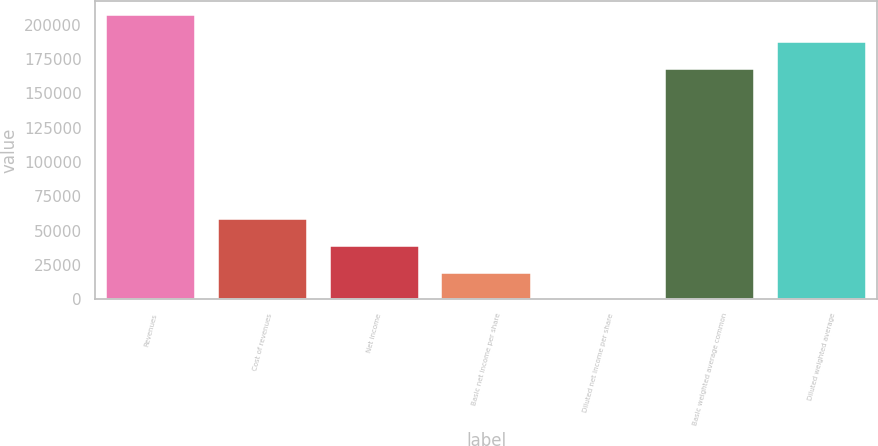Convert chart. <chart><loc_0><loc_0><loc_500><loc_500><bar_chart><fcel>Revenues<fcel>Cost of revenues<fcel>Net income<fcel>Basic net income per share<fcel>Diluted net income per share<fcel>Basic weighted average common<fcel>Diluted weighted average<nl><fcel>207041<fcel>58201.3<fcel>38800.9<fcel>19400.6<fcel>0.19<fcel>167417<fcel>187641<nl></chart> 